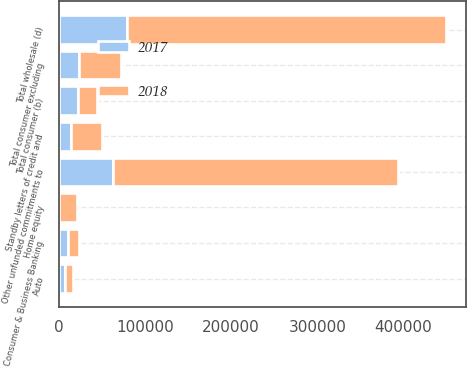Convert chart. <chart><loc_0><loc_0><loc_500><loc_500><stacked_bar_chart><ecel><fcel>Home equity<fcel>Auto<fcel>Consumer & Business Banking<fcel>Total consumer excluding<fcel>Total consumer (b)<fcel>Other unfunded commitments to<fcel>Standby letters of credit and<fcel>Total wholesale (d)<nl><fcel>2017<fcel>796<fcel>6954<fcel>10580<fcel>23799<fcel>22079.5<fcel>62384<fcel>14408<fcel>79400<nl><fcel>2018<fcel>20360<fcel>9255<fcel>13202<fcel>48553<fcel>22079.5<fcel>331160<fcel>35226<fcel>370098<nl></chart> 